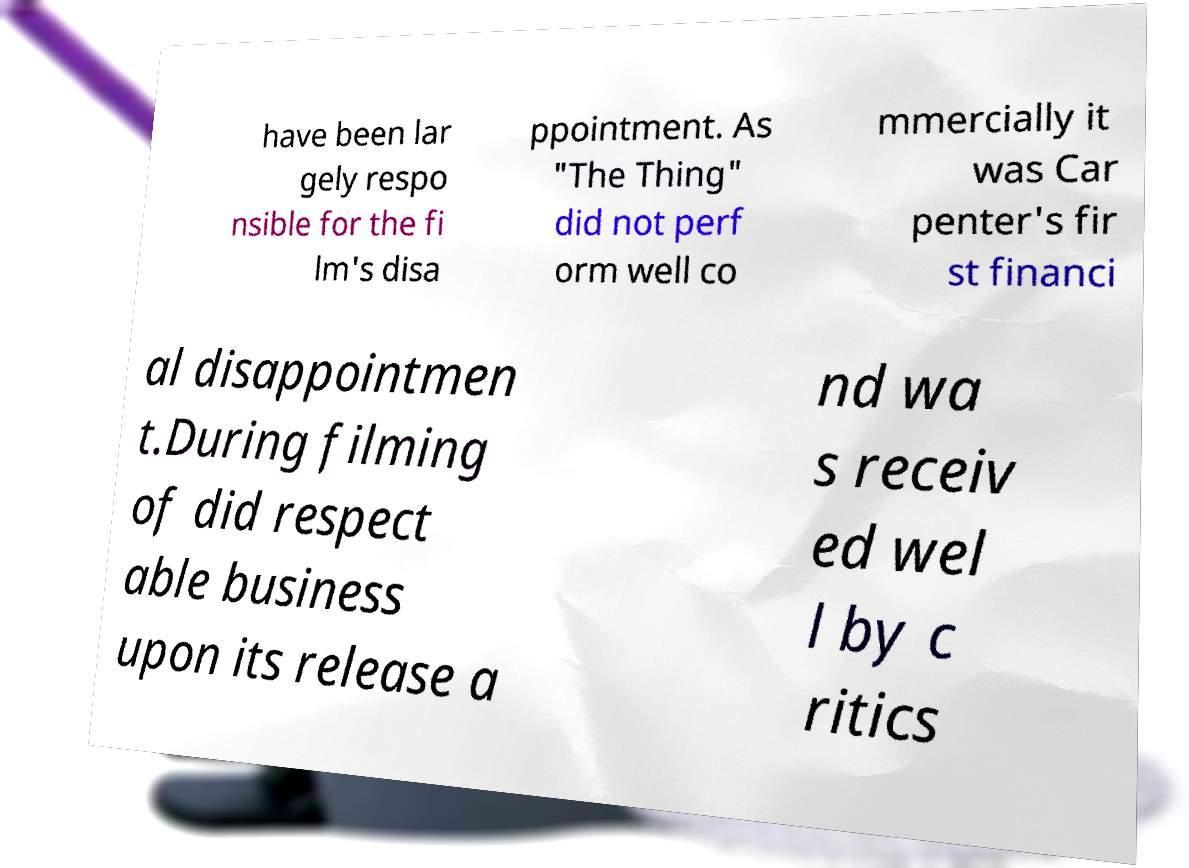Please identify and transcribe the text found in this image. have been lar gely respo nsible for the fi lm's disa ppointment. As "The Thing" did not perf orm well co mmercially it was Car penter's fir st financi al disappointmen t.During filming of did respect able business upon its release a nd wa s receiv ed wel l by c ritics 